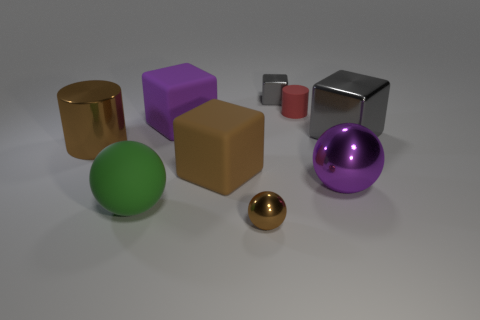There is a gray object that is the same size as the red matte cylinder; what is its shape? cube 